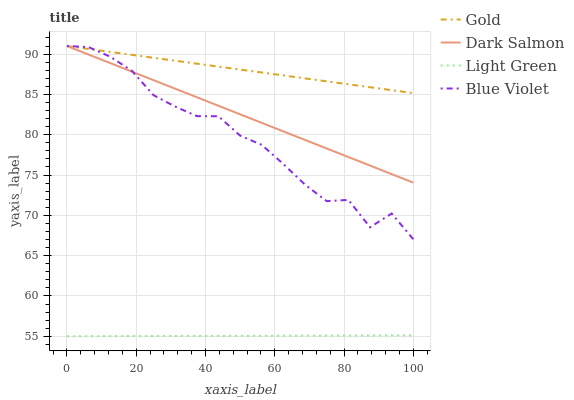Does Light Green have the minimum area under the curve?
Answer yes or no. Yes. Does Gold have the maximum area under the curve?
Answer yes or no. Yes. Does Dark Salmon have the minimum area under the curve?
Answer yes or no. No. Does Dark Salmon have the maximum area under the curve?
Answer yes or no. No. Is Light Green the smoothest?
Answer yes or no. Yes. Is Blue Violet the roughest?
Answer yes or no. Yes. Is Dark Salmon the smoothest?
Answer yes or no. No. Is Dark Salmon the roughest?
Answer yes or no. No. Does Dark Salmon have the lowest value?
Answer yes or no. No. Does Gold have the highest value?
Answer yes or no. Yes. Does Light Green have the highest value?
Answer yes or no. No. Is Light Green less than Blue Violet?
Answer yes or no. Yes. Is Gold greater than Light Green?
Answer yes or no. Yes. Does Dark Salmon intersect Blue Violet?
Answer yes or no. Yes. Is Dark Salmon less than Blue Violet?
Answer yes or no. No. Is Dark Salmon greater than Blue Violet?
Answer yes or no. No. Does Light Green intersect Blue Violet?
Answer yes or no. No. 